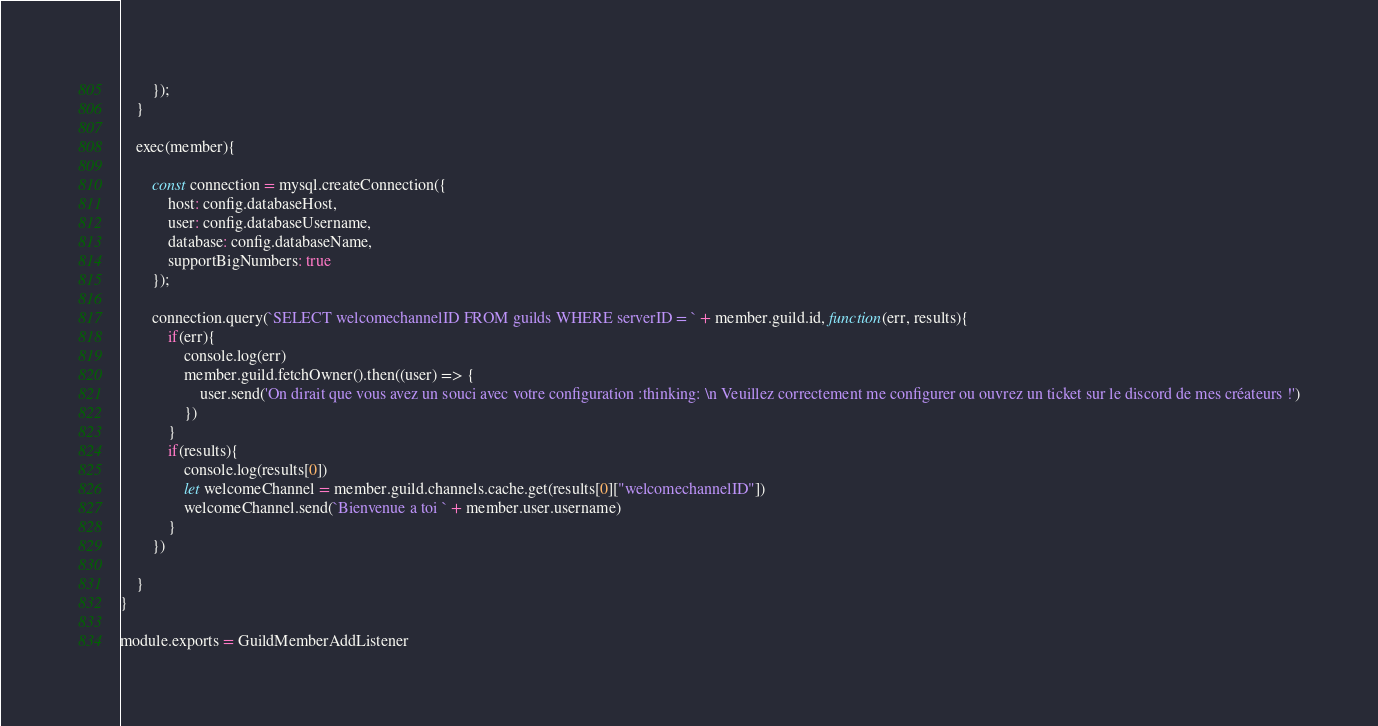Convert code to text. <code><loc_0><loc_0><loc_500><loc_500><_JavaScript_>        });
    }

    exec(member){

        const connection = mysql.createConnection({
            host: config.databaseHost,
            user: config.databaseUsername,
            database: config.databaseName,
            supportBigNumbers: true
        });

        connection.query(`SELECT welcomechannelID FROM guilds WHERE serverID = ` + member.guild.id, function(err, results){
            if(err){
                console.log(err)
                member.guild.fetchOwner().then((user) => {
                    user.send('On dirait que vous avez un souci avec votre configuration :thinking: \n Veuillez correctement me configurer ou ouvrez un ticket sur le discord de mes créateurs !')
                })
            }
            if(results){
                console.log(results[0])
                let welcomeChannel = member.guild.channels.cache.get(results[0]["welcomechannelID"])
                welcomeChannel.send(`Bienvenue a toi ` + member.user.username)
            }
        })

    }
}

module.exports = GuildMemberAddListener</code> 